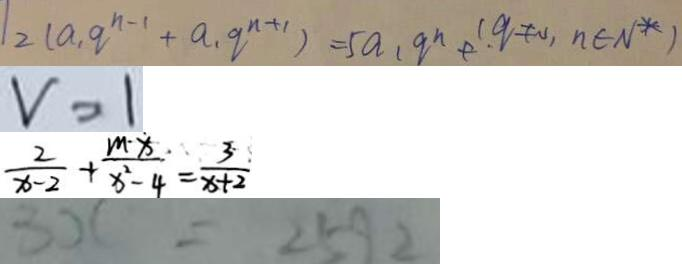<formula> <loc_0><loc_0><loc_500><loc_500>1 2 ( a _ { 1 } q ^ { n - 1 } + a _ { 1 } q ^ { n + 1 } ) = 5 a _ { 1 } q ^ { n } + . ( q \neq 0 , n \in N ^ { \ast } ) 
 v = 1 
 \frac { 2 } { x - 2 } + \frac { m \cdot x } { x ^ { 2 } - 4 } = \frac { 3 } { x + 2 } 
 3 x = 2 5 9 2</formula> 